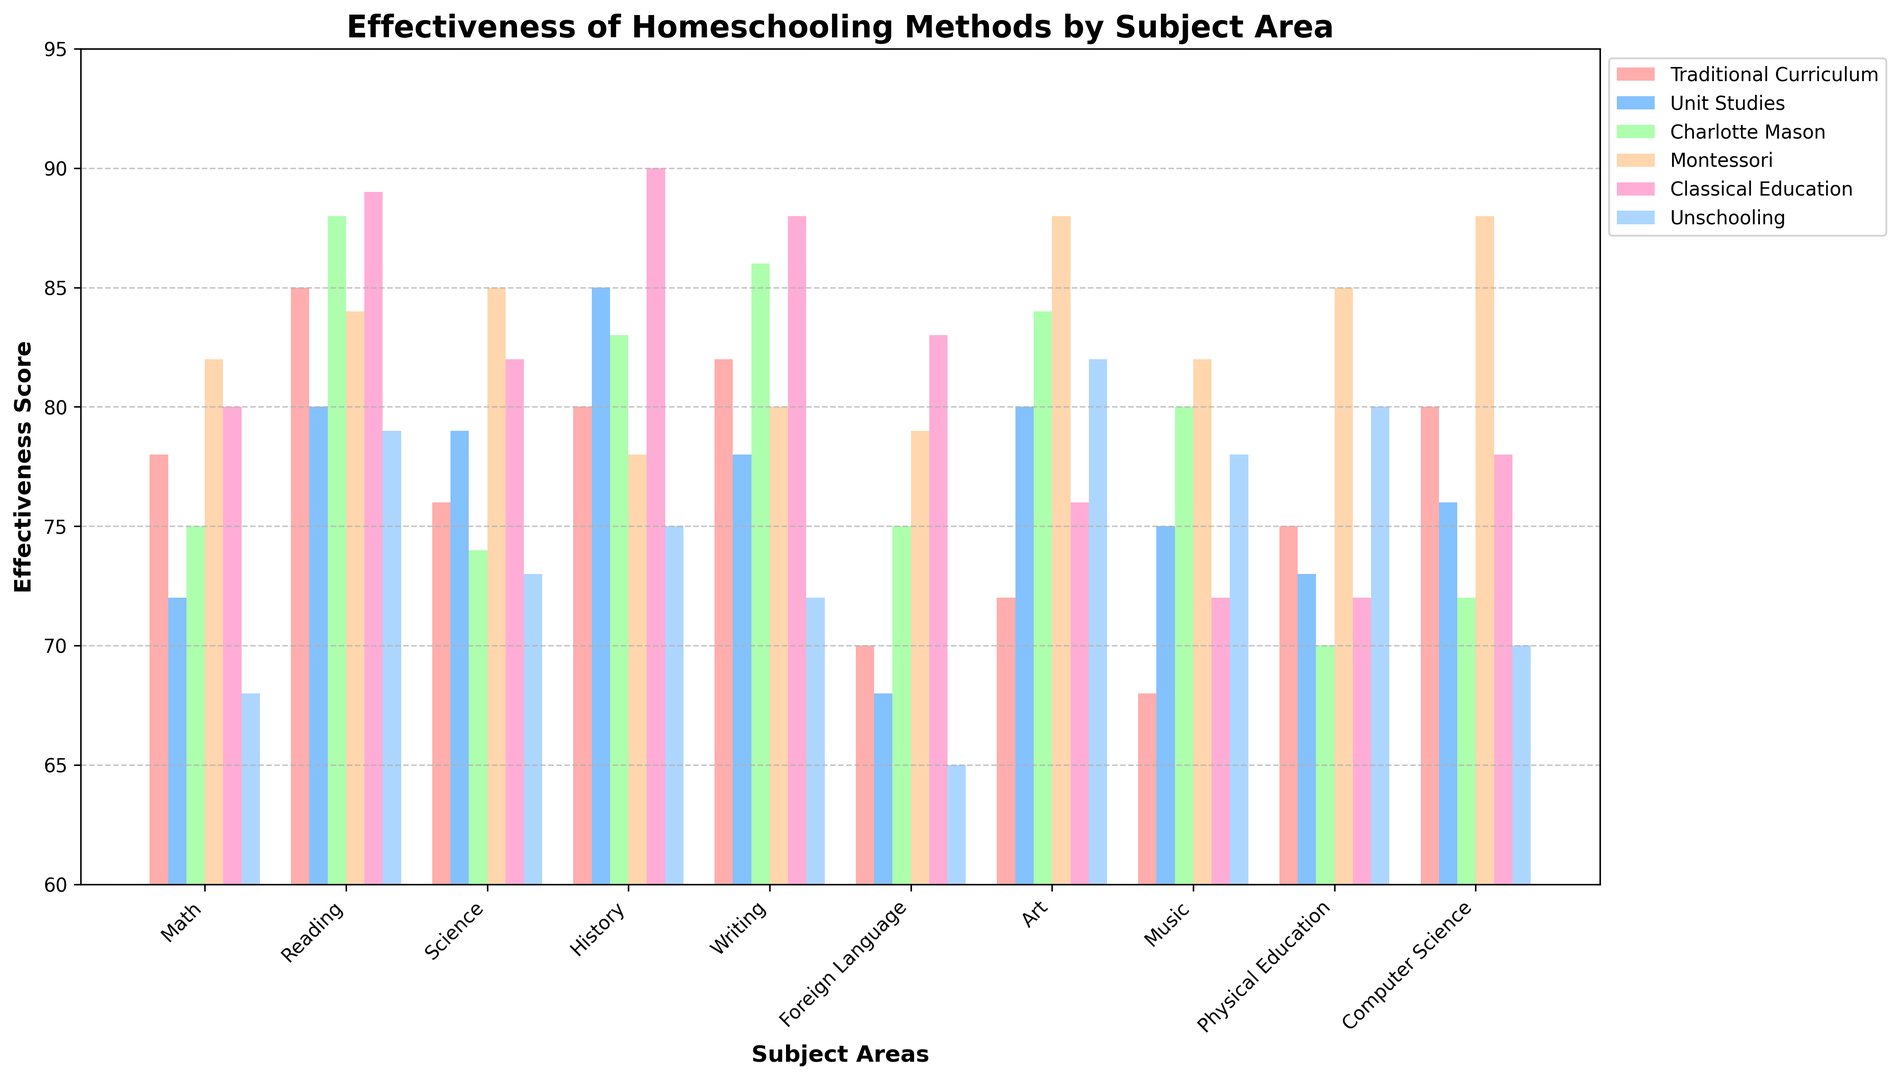Which homeschooling method is most effective for teaching Science? Compare the heights of the bars representing Science for each homeschooling method. The lowest bar is for "Unschooling" at 73, while the highest bar belongs to "Montessori" at 85.
Answer: Montessori Which homeschooling method has the highest effectiveness score for Writing? Compare the bars for Writing across all methods. The "Classical Education" method shows the highest effectiveness score with 88.
Answer: Classical Education Which subject shows the lowest effectiveness score for Unschooling? Locate the bars for Unschooling across all subjects. The shortest bar for Unschooling is in Foreign Language at 65.
Answer: Foreign Language What is the average effectiveness score for Classical Education across all subjects? Add up the effectiveness scores for Classical Education across all subjects and divide by the number of subjects: (80 + 89 + 82 + 90 + 88 + 83 + 76 + 72 + 72 + 78) = 810. The average is 810 / 10 = 81.
Answer: 81 Which methods have higher effectiveness scores for Reading than for Math? Compare the bars for Reading and Math for each method. Only "Charlotte Mason" and "Classical Education" methods have a higher score in Reading (88 and 89) compared to Math (75 and 80).
Answer: Charlotte Mason, Classical Education How much higher is the effectiveness score for Physical Education in Montessori compared to Traditional Curriculum? Find the bars for Physical Education. Montessori has a score of 85, and Traditional Curriculum has a score of 75. Subtract 75 from 85: 85 - 75 = 10.
Answer: 10 Which subject sees maximum variance in effectiveness scores among the methods? Compare the variance in bar heights across subjects. Art displays variance from 72 in Traditional Curriculum to 88 in Montessori, showing the widest range.
Answer: Art For which subject and method combination is the effectiveness score exactly 80? Look for bars in all subjects and methods with a score of 80. The "Classical Education" method for Math and Writing and the "Traditional Curriculum" for Computer Science shows an effectiveness of 80.
Answer: Classical Education (Math, Writing), Traditional Curriculum (Computer Science) Which subject does the Unschooling method show better effectiveness than at least one other method? Compare Unschooling with other methods per subject. For "Art," Unschooling (82) shows better effectiveness than Traditional Curriculum (72) and Classical Education (76).
Answer: Art 